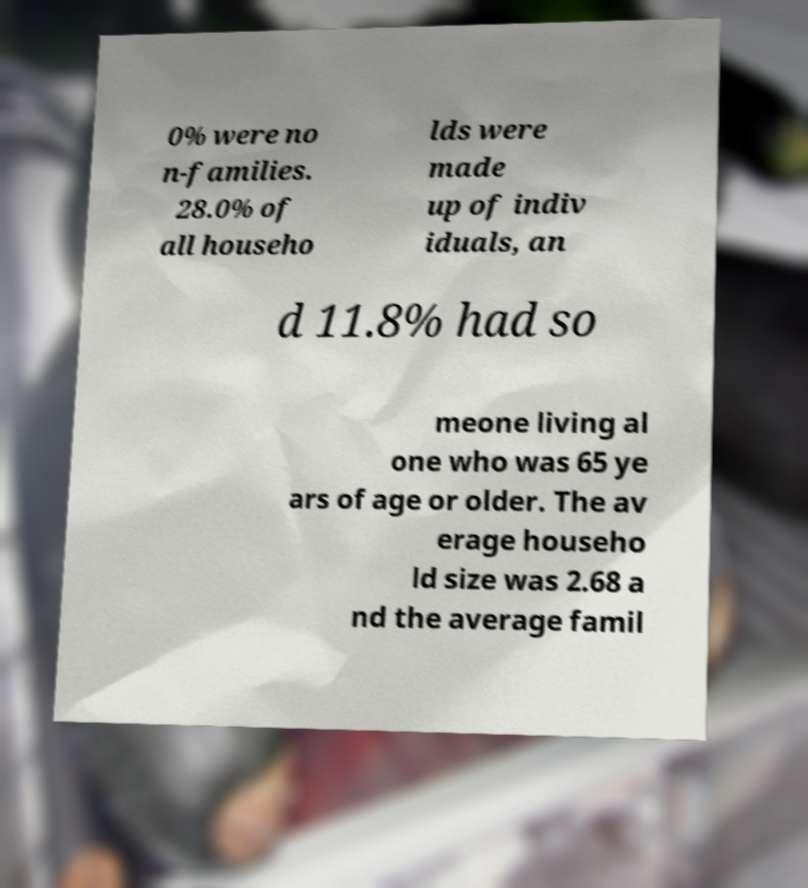Please read and relay the text visible in this image. What does it say? 0% were no n-families. 28.0% of all househo lds were made up of indiv iduals, an d 11.8% had so meone living al one who was 65 ye ars of age or older. The av erage househo ld size was 2.68 a nd the average famil 